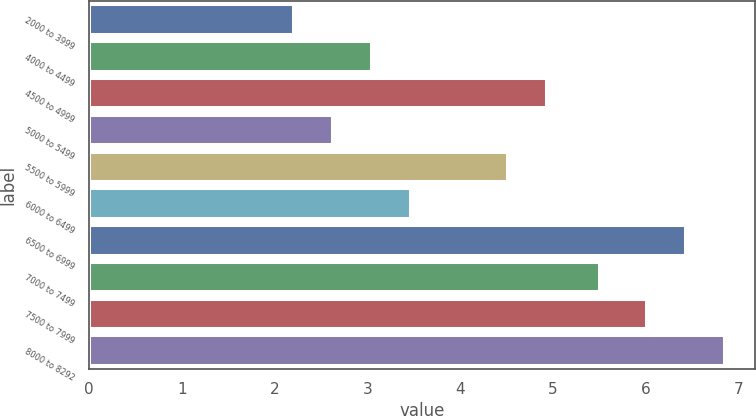Convert chart to OTSL. <chart><loc_0><loc_0><loc_500><loc_500><bar_chart><fcel>2000 to 3999<fcel>4000 to 4499<fcel>4500 to 4999<fcel>5000 to 5499<fcel>5500 to 5999<fcel>6000 to 6499<fcel>6500 to 6999<fcel>7000 to 7499<fcel>7500 to 7999<fcel>8000 to 8292<nl><fcel>2.2<fcel>3.04<fcel>4.92<fcel>2.62<fcel>4.5<fcel>3.46<fcel>6.42<fcel>5.5<fcel>6<fcel>6.84<nl></chart> 